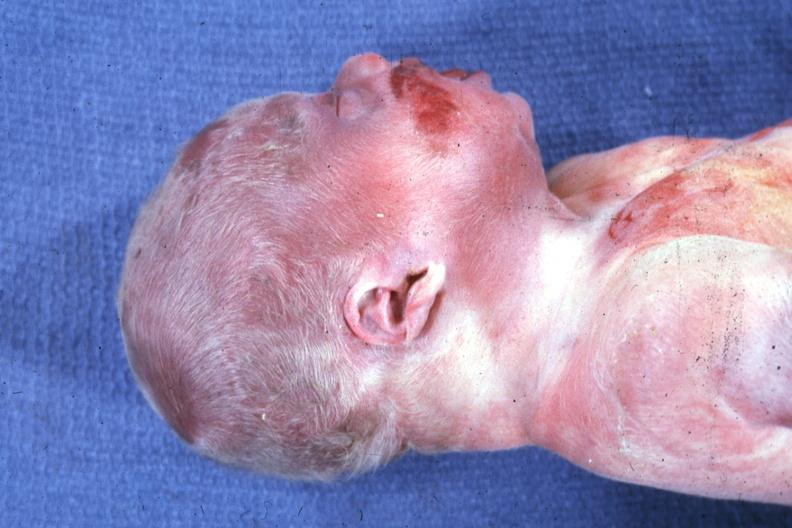s angiogram present?
Answer the question using a single word or phrase. No 